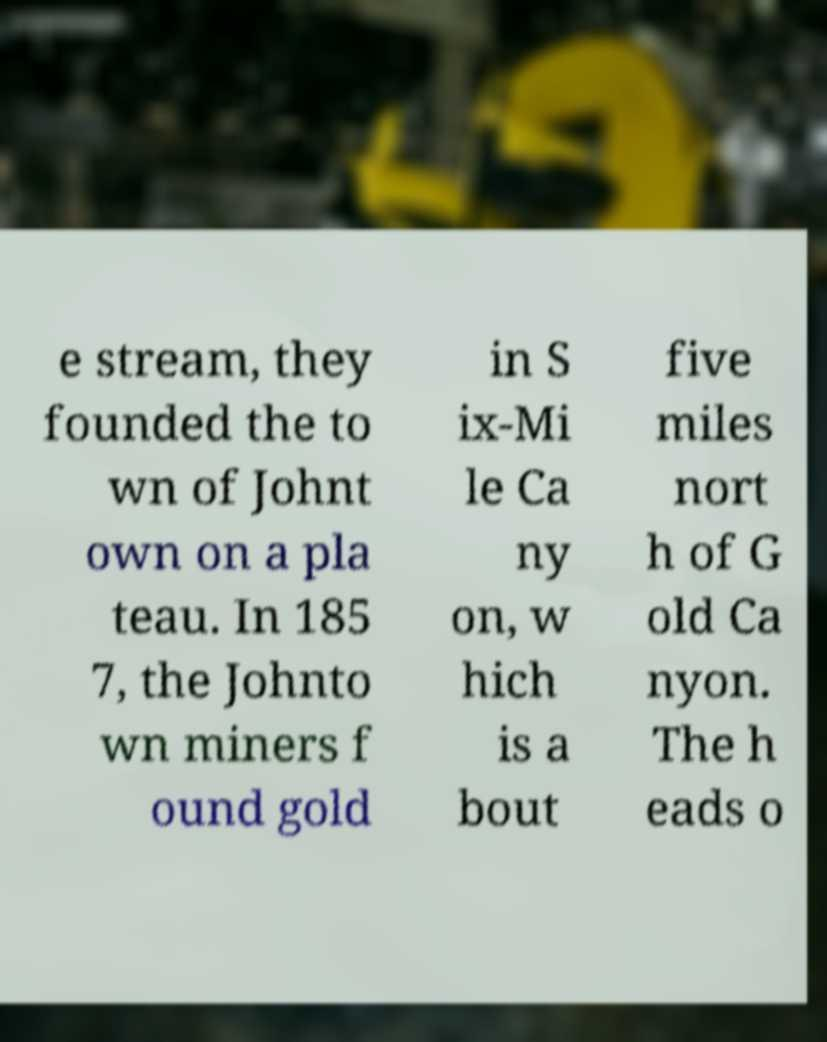Could you extract and type out the text from this image? e stream, they founded the to wn of Johnt own on a pla teau. In 185 7, the Johnto wn miners f ound gold in S ix-Mi le Ca ny on, w hich is a bout five miles nort h of G old Ca nyon. The h eads o 